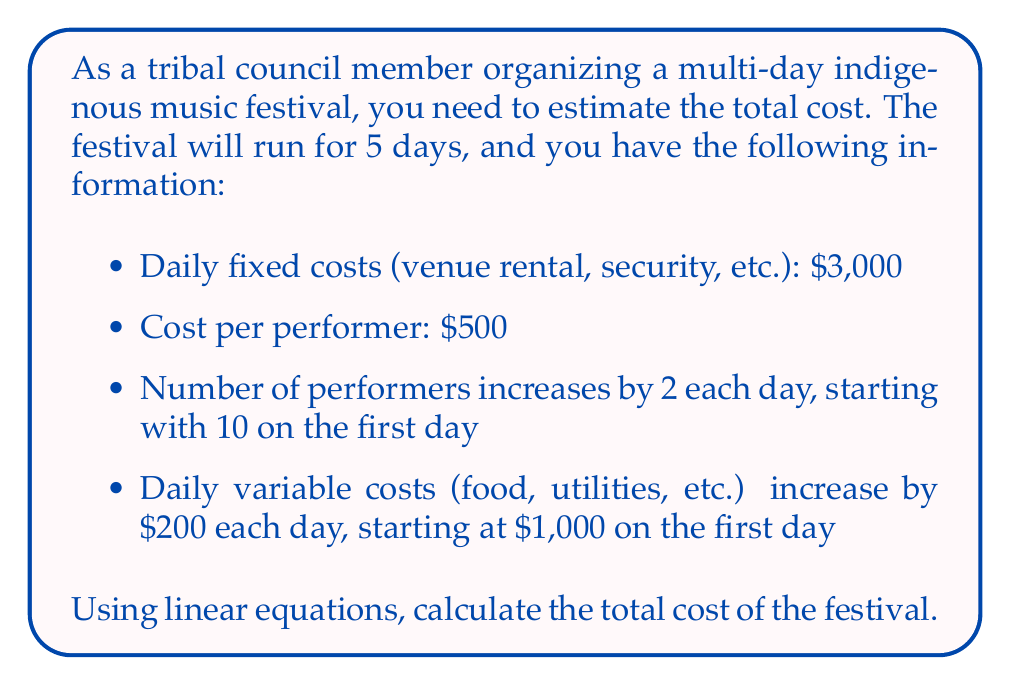Help me with this question. Let's break this problem down step by step:

1) First, let's define our variables:
   $x$ = day number (1 to 5)
   $y$ = total cost for each day

2) We can express the number of performers on each day as:
   $10 + 2(x-1)$ = performers on day $x$

3) The daily variable costs can be expressed as:
   $1000 + 200(x-1)$ = variable costs on day $x$

4) Now we can create a linear equation for the cost of each day:
   $y = 3000 + 500[10 + 2(x-1)] + [1000 + 200(x-1)]$

5) Simplify the equation:
   $y = 3000 + 5000 + 1000(x-1) + 1000 + 200(x-1)$
   $y = 9000 + 1200x - 1200$
   $y = 1200x + 7800$

6) To find the total cost, we need to sum this equation for $x$ from 1 to 5:
   $\text{Total Cost} = \sum_{x=1}^5 (1200x + 7800)$

7) This can be calculated as:
   $\text{Total Cost} = 1200(1+2+3+4+5) + 5(7800)$
   $= 1200(15) + 39000$
   $= 18000 + 39000$
   $= 57000$

Therefore, the total cost of the festival is $57,000.
Answer: $57,000 